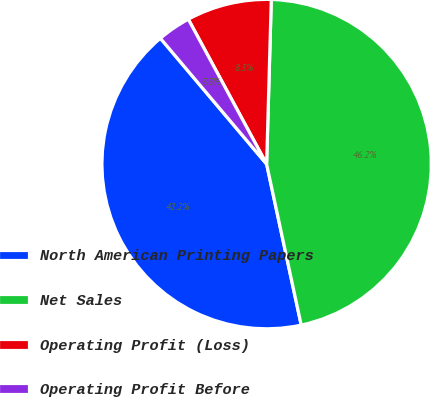Convert chart to OTSL. <chart><loc_0><loc_0><loc_500><loc_500><pie_chart><fcel>North American Printing Papers<fcel>Net Sales<fcel>Operating Profit (Loss)<fcel>Operating Profit Before<nl><fcel>42.21%<fcel>46.18%<fcel>8.34%<fcel>3.27%<nl></chart> 